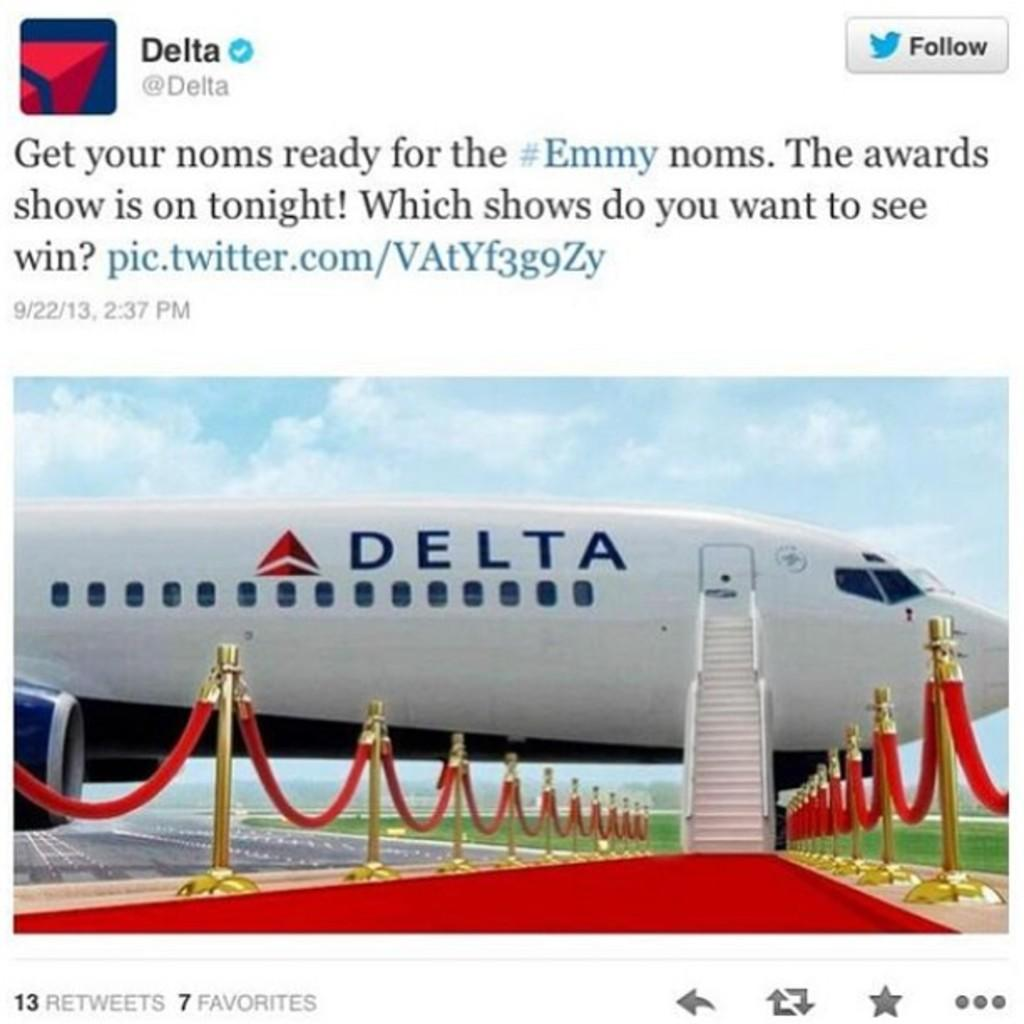Provide a one-sentence caption for the provided image. A tweet by Delta airlines showing a commercial jet with a red carpet leading to it. 